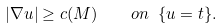<formula> <loc_0><loc_0><loc_500><loc_500>| \nabla u | \geq c ( M ) \quad o n \ \{ u = t \} .</formula> 